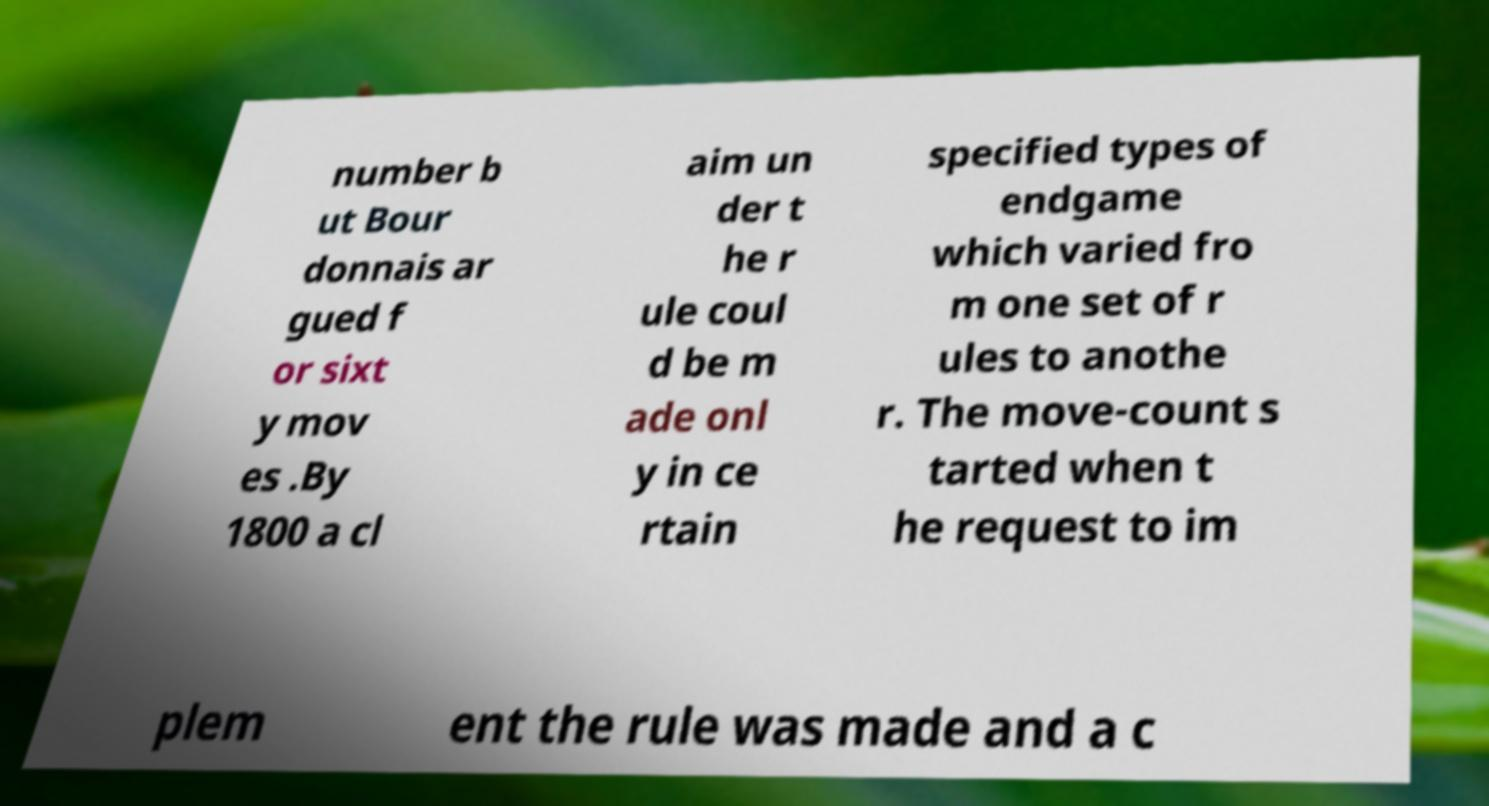Please identify and transcribe the text found in this image. number b ut Bour donnais ar gued f or sixt y mov es .By 1800 a cl aim un der t he r ule coul d be m ade onl y in ce rtain specified types of endgame which varied fro m one set of r ules to anothe r. The move-count s tarted when t he request to im plem ent the rule was made and a c 